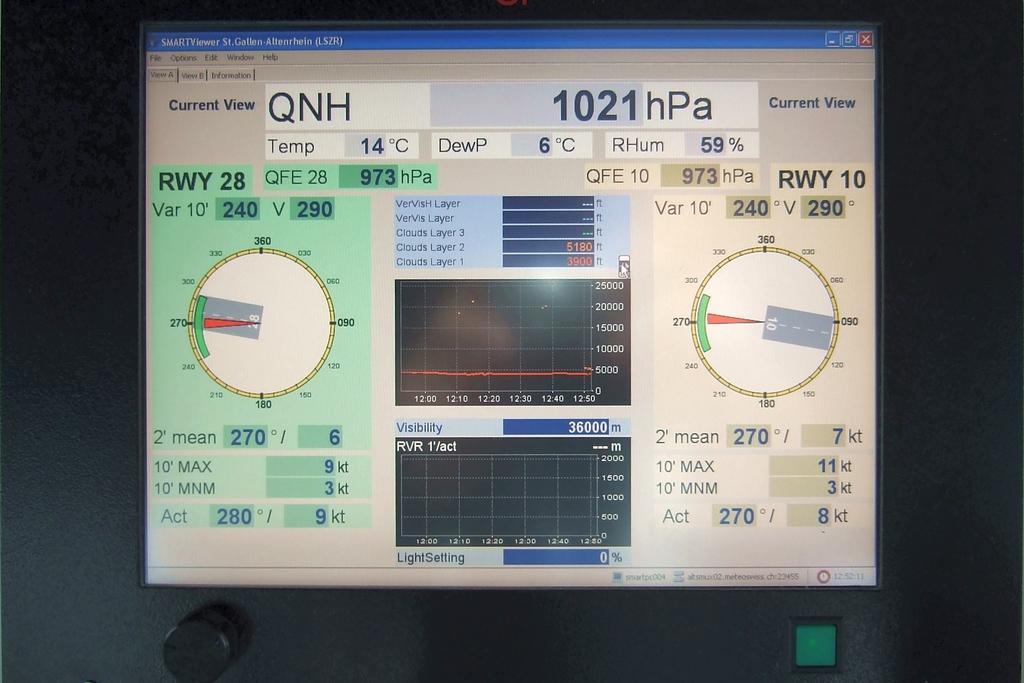What does the green sign say?
Your answer should be very brief. Rwy 28. What is the temperature in celsius?
Give a very brief answer. 14. 